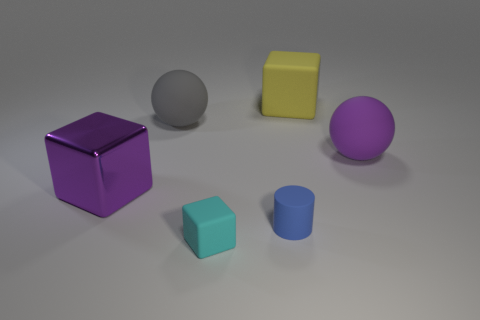Do the yellow thing and the big sphere in front of the large gray object have the same material? Although the image does not provide direct evidence regarding material properties, based on the similar matte appearance and reflections, it is plausible that the yellow cube and the large gray sphere could be made of the same or similar types of materials, such as plastic. However, without tactile or more detailed visual information, we cannot determine this with absolute certainty. 